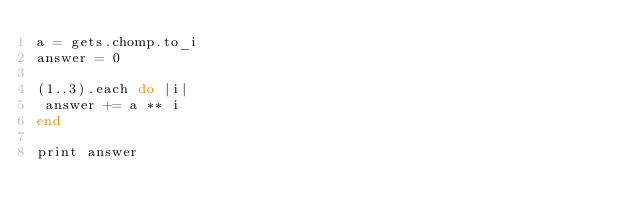<code> <loc_0><loc_0><loc_500><loc_500><_Ruby_>a = gets.chomp.to_i
answer = 0

(1..3).each do |i|
 answer += a ** i
end

print answer</code> 